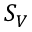<formula> <loc_0><loc_0><loc_500><loc_500>S _ { V }</formula> 